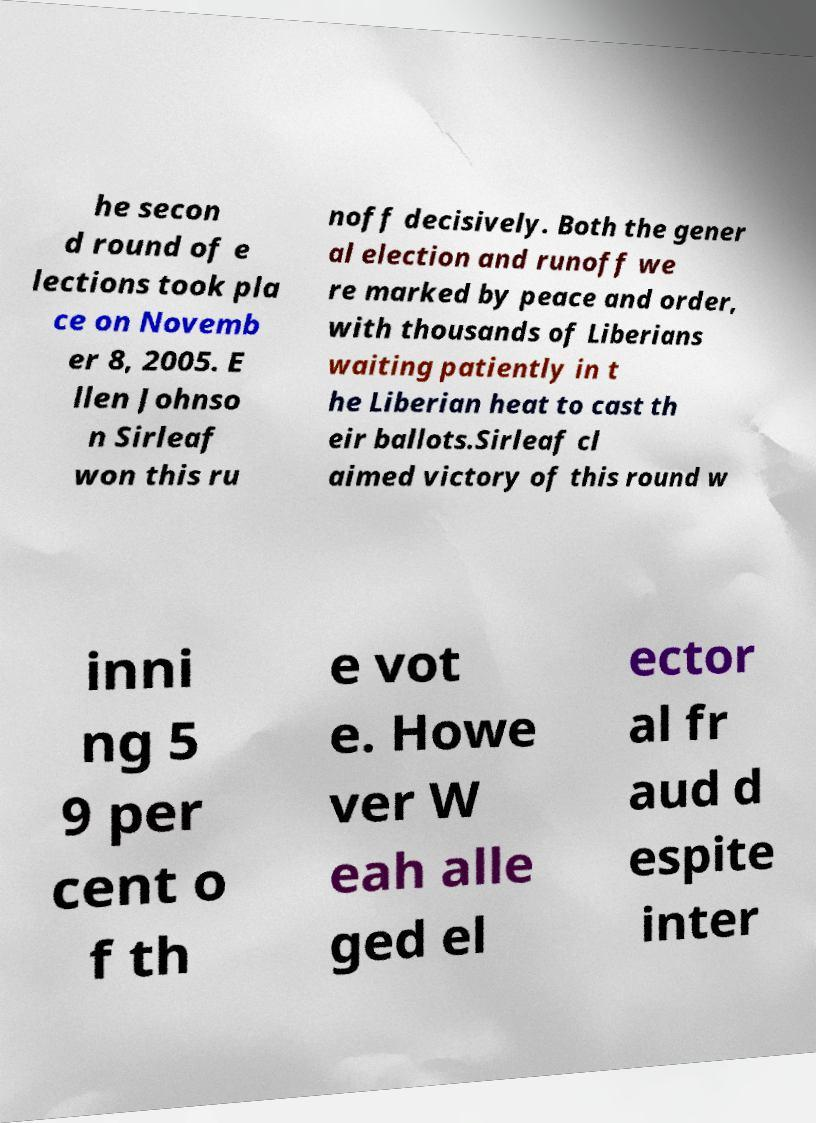There's text embedded in this image that I need extracted. Can you transcribe it verbatim? he secon d round of e lections took pla ce on Novemb er 8, 2005. E llen Johnso n Sirleaf won this ru noff decisively. Both the gener al election and runoff we re marked by peace and order, with thousands of Liberians waiting patiently in t he Liberian heat to cast th eir ballots.Sirleaf cl aimed victory of this round w inni ng 5 9 per cent o f th e vot e. Howe ver W eah alle ged el ector al fr aud d espite inter 